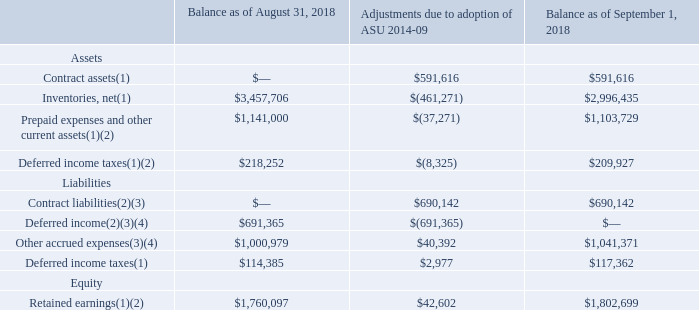18. Revenue
Effective September 1, 2018, the Company adopted ASU 2014-09, Revenue Recognition (Topic 606). The new standard is a comprehensive new revenue recognition model that requires the Company to recognize revenue in a manner which depicts the transfer of goods or services to its customers at an amount that reflects the consideration the Company expects to receive in exchange for those goods or services.
Prior to the adoption of the new standard, the Company recognized substantially all of its revenue from contracts with customers at a point in time, which was generally when the goods were shipped to or received by the customer, title and risk of ownership had passed, the price to the buyer was fixed or determinable and collectability was reasonably assured (net of estimated returns). Under the new standard, the Company recognizes revenue over time for the majority of its contracts with customers which results in revenue for those customers being recognized earlier than under the previous guidance. Revenue for all other contracts with customers continues to be recognized at a point in time, similar to recognition prior to the adoption of the standard.
Additionally, the new standard impacts the Company’s accounting for certain fulfillment costs, which include upfront costs to prepare for manufacturing activities that are expected to be recovered. Under the new standard, such upfront costs are recognized as an asset and amortized on a systematic basis consistent with the pattern of the transfer of control of the products or services to which to the asset relates.
The Company adopted ASU 2014-09 using the modified retrospective method by applying the guidance to all open contracts upon adoption and recorded a cumulative effect adjustment as of September 1, 2018, net of tax,  effect adjustment (in thousands):
(1) Differences primarily relate to the timing of revenue recognition for over time customers and certain balance sheet reclassifications.
(2) Differences primarily relate to the timing of recognition and recovery of fulfillment costs and certain balance sheet reclassifications.
(3) Included within accrued expenses on the Consolidated Balance Sheets.
(4) Differences included in contract liabilities as of September 1, 2018.
What were the Adjustments due to adoption of ASU 2014-09 for contract assets?
Answer scale should be: thousand. $591,616. What does the new standard entail? A comprehensive new revenue recognition model that requires the company to recognize revenue in a manner which depicts the transfer of goods or services to its customers at an amount that reflects the consideration the company expects to receive in exchange for those goods or services. What was the balance as of September 1, 2018 for contract liabilities?
Answer scale should be: thousand. $690,142. What is the difference between the balance in September 2018 for contract assets and contract liabilities?
Answer scale should be: thousand. 690,142-591,616
Answer: 98526. What was the percentage change for Other accrued expenses due to adjustments by the new standard?
Answer scale should be: percent. $40,392/$1,000,979
Answer: 4.04. What was the percentage change in the balance of retained earnings due to adjustments by the new standard?
Answer scale should be: percent. (1,802,699-1,760,097)/1,760,097
Answer: 2.42. 